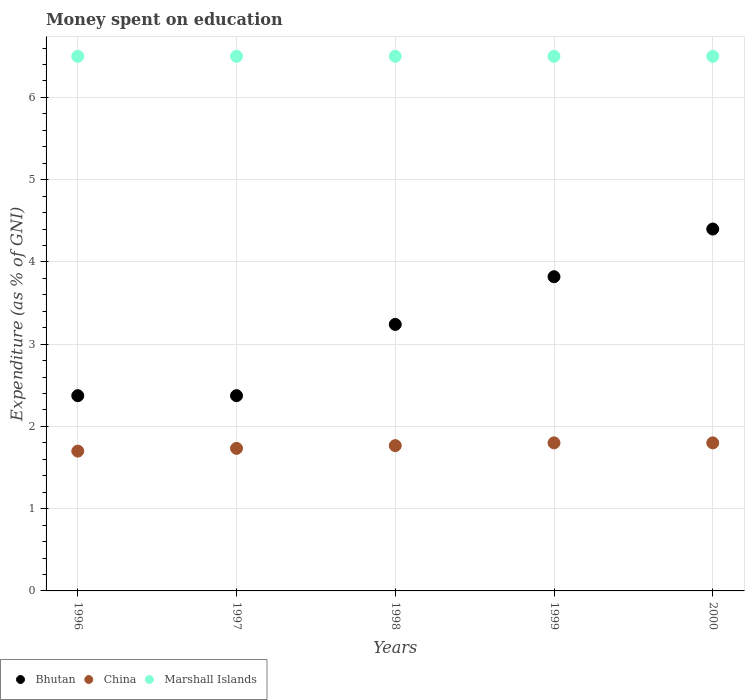How many different coloured dotlines are there?
Provide a short and direct response. 3. Is the number of dotlines equal to the number of legend labels?
Offer a terse response. Yes. What is the amount of money spent on education in China in 1998?
Offer a very short reply. 1.77. Across all years, what is the maximum amount of money spent on education in Marshall Islands?
Offer a very short reply. 6.5. Across all years, what is the minimum amount of money spent on education in China?
Offer a terse response. 1.7. In which year was the amount of money spent on education in Bhutan minimum?
Provide a short and direct response. 1996. What is the total amount of money spent on education in Bhutan in the graph?
Offer a terse response. 16.21. What is the difference between the amount of money spent on education in Marshall Islands in 1996 and that in 2000?
Give a very brief answer. 0. What is the difference between the amount of money spent on education in Marshall Islands in 1997 and the amount of money spent on education in Bhutan in 1996?
Provide a succinct answer. 4.13. What is the average amount of money spent on education in Bhutan per year?
Keep it short and to the point. 3.24. What is the ratio of the amount of money spent on education in China in 1996 to that in 1998?
Your answer should be compact. 0.96. What is the difference between the highest and the second highest amount of money spent on education in Bhutan?
Offer a very short reply. 0.58. What is the difference between the highest and the lowest amount of money spent on education in China?
Give a very brief answer. 0.1. In how many years, is the amount of money spent on education in Bhutan greater than the average amount of money spent on education in Bhutan taken over all years?
Your answer should be very brief. 2. Is the sum of the amount of money spent on education in China in 1996 and 1999 greater than the maximum amount of money spent on education in Marshall Islands across all years?
Offer a terse response. No. Is it the case that in every year, the sum of the amount of money spent on education in China and amount of money spent on education in Bhutan  is greater than the amount of money spent on education in Marshall Islands?
Provide a succinct answer. No. Does the amount of money spent on education in China monotonically increase over the years?
Your answer should be compact. No. How many dotlines are there?
Give a very brief answer. 3. Are the values on the major ticks of Y-axis written in scientific E-notation?
Your answer should be compact. No. Does the graph contain grids?
Make the answer very short. Yes. Where does the legend appear in the graph?
Make the answer very short. Bottom left. How many legend labels are there?
Your answer should be compact. 3. How are the legend labels stacked?
Provide a succinct answer. Horizontal. What is the title of the graph?
Your answer should be compact. Money spent on education. What is the label or title of the X-axis?
Your response must be concise. Years. What is the label or title of the Y-axis?
Make the answer very short. Expenditure (as % of GNI). What is the Expenditure (as % of GNI) of Bhutan in 1996?
Your answer should be compact. 2.37. What is the Expenditure (as % of GNI) in China in 1996?
Offer a terse response. 1.7. What is the Expenditure (as % of GNI) in Bhutan in 1997?
Offer a terse response. 2.37. What is the Expenditure (as % of GNI) of China in 1997?
Provide a succinct answer. 1.73. What is the Expenditure (as % of GNI) in Marshall Islands in 1997?
Give a very brief answer. 6.5. What is the Expenditure (as % of GNI) in Bhutan in 1998?
Offer a very short reply. 3.24. What is the Expenditure (as % of GNI) in China in 1998?
Provide a short and direct response. 1.77. What is the Expenditure (as % of GNI) in Marshall Islands in 1998?
Give a very brief answer. 6.5. What is the Expenditure (as % of GNI) of Bhutan in 1999?
Your answer should be very brief. 3.82. What is the Expenditure (as % of GNI) of Marshall Islands in 1999?
Give a very brief answer. 6.5. Across all years, what is the minimum Expenditure (as % of GNI) in Bhutan?
Provide a short and direct response. 2.37. What is the total Expenditure (as % of GNI) in Bhutan in the graph?
Offer a very short reply. 16.21. What is the total Expenditure (as % of GNI) of Marshall Islands in the graph?
Your answer should be very brief. 32.5. What is the difference between the Expenditure (as % of GNI) of China in 1996 and that in 1997?
Ensure brevity in your answer.  -0.03. What is the difference between the Expenditure (as % of GNI) in Marshall Islands in 1996 and that in 1997?
Ensure brevity in your answer.  0. What is the difference between the Expenditure (as % of GNI) in Bhutan in 1996 and that in 1998?
Keep it short and to the point. -0.87. What is the difference between the Expenditure (as % of GNI) of China in 1996 and that in 1998?
Provide a short and direct response. -0.07. What is the difference between the Expenditure (as % of GNI) of Marshall Islands in 1996 and that in 1998?
Offer a terse response. 0. What is the difference between the Expenditure (as % of GNI) in Bhutan in 1996 and that in 1999?
Make the answer very short. -1.45. What is the difference between the Expenditure (as % of GNI) of Bhutan in 1996 and that in 2000?
Ensure brevity in your answer.  -2.03. What is the difference between the Expenditure (as % of GNI) in Marshall Islands in 1996 and that in 2000?
Provide a succinct answer. 0. What is the difference between the Expenditure (as % of GNI) of Bhutan in 1997 and that in 1998?
Offer a terse response. -0.87. What is the difference between the Expenditure (as % of GNI) of China in 1997 and that in 1998?
Your answer should be very brief. -0.03. What is the difference between the Expenditure (as % of GNI) of Marshall Islands in 1997 and that in 1998?
Your answer should be very brief. 0. What is the difference between the Expenditure (as % of GNI) of Bhutan in 1997 and that in 1999?
Ensure brevity in your answer.  -1.45. What is the difference between the Expenditure (as % of GNI) of China in 1997 and that in 1999?
Make the answer very short. -0.07. What is the difference between the Expenditure (as % of GNI) in Bhutan in 1997 and that in 2000?
Your answer should be very brief. -2.03. What is the difference between the Expenditure (as % of GNI) of China in 1997 and that in 2000?
Offer a very short reply. -0.07. What is the difference between the Expenditure (as % of GNI) of Bhutan in 1998 and that in 1999?
Make the answer very short. -0.58. What is the difference between the Expenditure (as % of GNI) in China in 1998 and that in 1999?
Ensure brevity in your answer.  -0.03. What is the difference between the Expenditure (as % of GNI) of Bhutan in 1998 and that in 2000?
Your response must be concise. -1.16. What is the difference between the Expenditure (as % of GNI) in China in 1998 and that in 2000?
Make the answer very short. -0.03. What is the difference between the Expenditure (as % of GNI) in Marshall Islands in 1998 and that in 2000?
Your response must be concise. 0. What is the difference between the Expenditure (as % of GNI) of Bhutan in 1999 and that in 2000?
Your answer should be very brief. -0.58. What is the difference between the Expenditure (as % of GNI) of China in 1999 and that in 2000?
Give a very brief answer. 0. What is the difference between the Expenditure (as % of GNI) of Marshall Islands in 1999 and that in 2000?
Offer a very short reply. 0. What is the difference between the Expenditure (as % of GNI) in Bhutan in 1996 and the Expenditure (as % of GNI) in China in 1997?
Provide a short and direct response. 0.64. What is the difference between the Expenditure (as % of GNI) of Bhutan in 1996 and the Expenditure (as % of GNI) of Marshall Islands in 1997?
Provide a short and direct response. -4.13. What is the difference between the Expenditure (as % of GNI) of China in 1996 and the Expenditure (as % of GNI) of Marshall Islands in 1997?
Offer a very short reply. -4.8. What is the difference between the Expenditure (as % of GNI) in Bhutan in 1996 and the Expenditure (as % of GNI) in China in 1998?
Provide a succinct answer. 0.61. What is the difference between the Expenditure (as % of GNI) in Bhutan in 1996 and the Expenditure (as % of GNI) in Marshall Islands in 1998?
Provide a short and direct response. -4.13. What is the difference between the Expenditure (as % of GNI) in China in 1996 and the Expenditure (as % of GNI) in Marshall Islands in 1998?
Provide a succinct answer. -4.8. What is the difference between the Expenditure (as % of GNI) of Bhutan in 1996 and the Expenditure (as % of GNI) of China in 1999?
Give a very brief answer. 0.57. What is the difference between the Expenditure (as % of GNI) in Bhutan in 1996 and the Expenditure (as % of GNI) in Marshall Islands in 1999?
Keep it short and to the point. -4.13. What is the difference between the Expenditure (as % of GNI) in Bhutan in 1996 and the Expenditure (as % of GNI) in China in 2000?
Keep it short and to the point. 0.57. What is the difference between the Expenditure (as % of GNI) in Bhutan in 1996 and the Expenditure (as % of GNI) in Marshall Islands in 2000?
Keep it short and to the point. -4.13. What is the difference between the Expenditure (as % of GNI) in China in 1996 and the Expenditure (as % of GNI) in Marshall Islands in 2000?
Your answer should be compact. -4.8. What is the difference between the Expenditure (as % of GNI) in Bhutan in 1997 and the Expenditure (as % of GNI) in China in 1998?
Offer a terse response. 0.61. What is the difference between the Expenditure (as % of GNI) in Bhutan in 1997 and the Expenditure (as % of GNI) in Marshall Islands in 1998?
Your response must be concise. -4.13. What is the difference between the Expenditure (as % of GNI) in China in 1997 and the Expenditure (as % of GNI) in Marshall Islands in 1998?
Provide a succinct answer. -4.77. What is the difference between the Expenditure (as % of GNI) in Bhutan in 1997 and the Expenditure (as % of GNI) in China in 1999?
Give a very brief answer. 0.57. What is the difference between the Expenditure (as % of GNI) of Bhutan in 1997 and the Expenditure (as % of GNI) of Marshall Islands in 1999?
Your answer should be very brief. -4.13. What is the difference between the Expenditure (as % of GNI) in China in 1997 and the Expenditure (as % of GNI) in Marshall Islands in 1999?
Offer a very short reply. -4.77. What is the difference between the Expenditure (as % of GNI) of Bhutan in 1997 and the Expenditure (as % of GNI) of China in 2000?
Give a very brief answer. 0.57. What is the difference between the Expenditure (as % of GNI) in Bhutan in 1997 and the Expenditure (as % of GNI) in Marshall Islands in 2000?
Ensure brevity in your answer.  -4.13. What is the difference between the Expenditure (as % of GNI) in China in 1997 and the Expenditure (as % of GNI) in Marshall Islands in 2000?
Offer a terse response. -4.77. What is the difference between the Expenditure (as % of GNI) in Bhutan in 1998 and the Expenditure (as % of GNI) in China in 1999?
Keep it short and to the point. 1.44. What is the difference between the Expenditure (as % of GNI) of Bhutan in 1998 and the Expenditure (as % of GNI) of Marshall Islands in 1999?
Give a very brief answer. -3.26. What is the difference between the Expenditure (as % of GNI) in China in 1998 and the Expenditure (as % of GNI) in Marshall Islands in 1999?
Offer a terse response. -4.73. What is the difference between the Expenditure (as % of GNI) of Bhutan in 1998 and the Expenditure (as % of GNI) of China in 2000?
Give a very brief answer. 1.44. What is the difference between the Expenditure (as % of GNI) in Bhutan in 1998 and the Expenditure (as % of GNI) in Marshall Islands in 2000?
Make the answer very short. -3.26. What is the difference between the Expenditure (as % of GNI) of China in 1998 and the Expenditure (as % of GNI) of Marshall Islands in 2000?
Keep it short and to the point. -4.73. What is the difference between the Expenditure (as % of GNI) in Bhutan in 1999 and the Expenditure (as % of GNI) in China in 2000?
Your answer should be very brief. 2.02. What is the difference between the Expenditure (as % of GNI) of Bhutan in 1999 and the Expenditure (as % of GNI) of Marshall Islands in 2000?
Offer a terse response. -2.68. What is the average Expenditure (as % of GNI) of Bhutan per year?
Offer a terse response. 3.24. What is the average Expenditure (as % of GNI) of China per year?
Give a very brief answer. 1.76. What is the average Expenditure (as % of GNI) of Marshall Islands per year?
Your response must be concise. 6.5. In the year 1996, what is the difference between the Expenditure (as % of GNI) of Bhutan and Expenditure (as % of GNI) of China?
Provide a succinct answer. 0.67. In the year 1996, what is the difference between the Expenditure (as % of GNI) in Bhutan and Expenditure (as % of GNI) in Marshall Islands?
Ensure brevity in your answer.  -4.13. In the year 1997, what is the difference between the Expenditure (as % of GNI) in Bhutan and Expenditure (as % of GNI) in China?
Your answer should be very brief. 0.64. In the year 1997, what is the difference between the Expenditure (as % of GNI) of Bhutan and Expenditure (as % of GNI) of Marshall Islands?
Provide a short and direct response. -4.13. In the year 1997, what is the difference between the Expenditure (as % of GNI) in China and Expenditure (as % of GNI) in Marshall Islands?
Provide a short and direct response. -4.77. In the year 1998, what is the difference between the Expenditure (as % of GNI) in Bhutan and Expenditure (as % of GNI) in China?
Offer a terse response. 1.47. In the year 1998, what is the difference between the Expenditure (as % of GNI) in Bhutan and Expenditure (as % of GNI) in Marshall Islands?
Your answer should be very brief. -3.26. In the year 1998, what is the difference between the Expenditure (as % of GNI) of China and Expenditure (as % of GNI) of Marshall Islands?
Offer a very short reply. -4.73. In the year 1999, what is the difference between the Expenditure (as % of GNI) of Bhutan and Expenditure (as % of GNI) of China?
Your response must be concise. 2.02. In the year 1999, what is the difference between the Expenditure (as % of GNI) of Bhutan and Expenditure (as % of GNI) of Marshall Islands?
Your answer should be compact. -2.68. In the year 2000, what is the difference between the Expenditure (as % of GNI) of Bhutan and Expenditure (as % of GNI) of China?
Your response must be concise. 2.6. In the year 2000, what is the difference between the Expenditure (as % of GNI) of China and Expenditure (as % of GNI) of Marshall Islands?
Provide a short and direct response. -4.7. What is the ratio of the Expenditure (as % of GNI) of China in 1996 to that in 1997?
Offer a terse response. 0.98. What is the ratio of the Expenditure (as % of GNI) in Marshall Islands in 1996 to that in 1997?
Offer a terse response. 1. What is the ratio of the Expenditure (as % of GNI) of Bhutan in 1996 to that in 1998?
Your answer should be compact. 0.73. What is the ratio of the Expenditure (as % of GNI) of China in 1996 to that in 1998?
Give a very brief answer. 0.96. What is the ratio of the Expenditure (as % of GNI) of Marshall Islands in 1996 to that in 1998?
Make the answer very short. 1. What is the ratio of the Expenditure (as % of GNI) of Bhutan in 1996 to that in 1999?
Give a very brief answer. 0.62. What is the ratio of the Expenditure (as % of GNI) in Marshall Islands in 1996 to that in 1999?
Offer a very short reply. 1. What is the ratio of the Expenditure (as % of GNI) in Bhutan in 1996 to that in 2000?
Make the answer very short. 0.54. What is the ratio of the Expenditure (as % of GNI) in China in 1996 to that in 2000?
Your response must be concise. 0.94. What is the ratio of the Expenditure (as % of GNI) in Bhutan in 1997 to that in 1998?
Keep it short and to the point. 0.73. What is the ratio of the Expenditure (as % of GNI) in China in 1997 to that in 1998?
Your answer should be very brief. 0.98. What is the ratio of the Expenditure (as % of GNI) of Marshall Islands in 1997 to that in 1998?
Ensure brevity in your answer.  1. What is the ratio of the Expenditure (as % of GNI) of Bhutan in 1997 to that in 1999?
Keep it short and to the point. 0.62. What is the ratio of the Expenditure (as % of GNI) in China in 1997 to that in 1999?
Make the answer very short. 0.96. What is the ratio of the Expenditure (as % of GNI) in Bhutan in 1997 to that in 2000?
Your answer should be compact. 0.54. What is the ratio of the Expenditure (as % of GNI) in Bhutan in 1998 to that in 1999?
Make the answer very short. 0.85. What is the ratio of the Expenditure (as % of GNI) in China in 1998 to that in 1999?
Your answer should be compact. 0.98. What is the ratio of the Expenditure (as % of GNI) in Marshall Islands in 1998 to that in 1999?
Ensure brevity in your answer.  1. What is the ratio of the Expenditure (as % of GNI) of Bhutan in 1998 to that in 2000?
Offer a terse response. 0.74. What is the ratio of the Expenditure (as % of GNI) of China in 1998 to that in 2000?
Provide a short and direct response. 0.98. What is the ratio of the Expenditure (as % of GNI) of Marshall Islands in 1998 to that in 2000?
Keep it short and to the point. 1. What is the ratio of the Expenditure (as % of GNI) in Bhutan in 1999 to that in 2000?
Your answer should be very brief. 0.87. What is the ratio of the Expenditure (as % of GNI) of China in 1999 to that in 2000?
Provide a short and direct response. 1. What is the ratio of the Expenditure (as % of GNI) of Marshall Islands in 1999 to that in 2000?
Offer a terse response. 1. What is the difference between the highest and the second highest Expenditure (as % of GNI) in Bhutan?
Offer a very short reply. 0.58. What is the difference between the highest and the second highest Expenditure (as % of GNI) in China?
Offer a terse response. 0. What is the difference between the highest and the lowest Expenditure (as % of GNI) in Bhutan?
Your response must be concise. 2.03. What is the difference between the highest and the lowest Expenditure (as % of GNI) of Marshall Islands?
Your response must be concise. 0. 